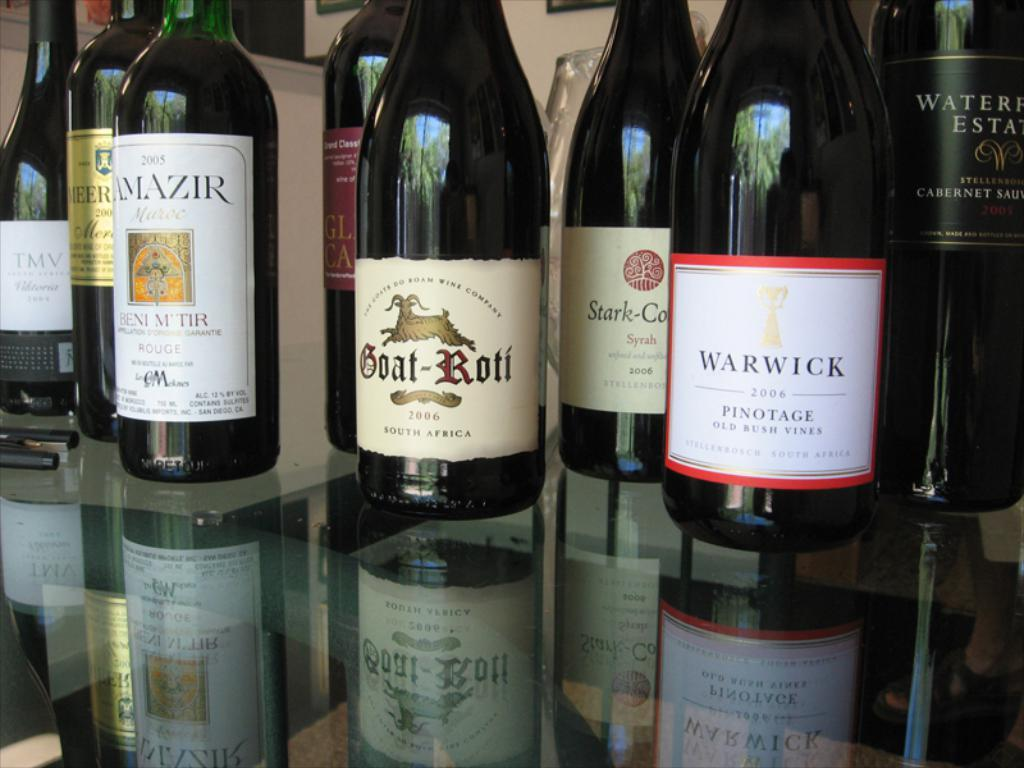<image>
Describe the image concisely. A shelf with wine bottles on it including one called Goat Roti. 